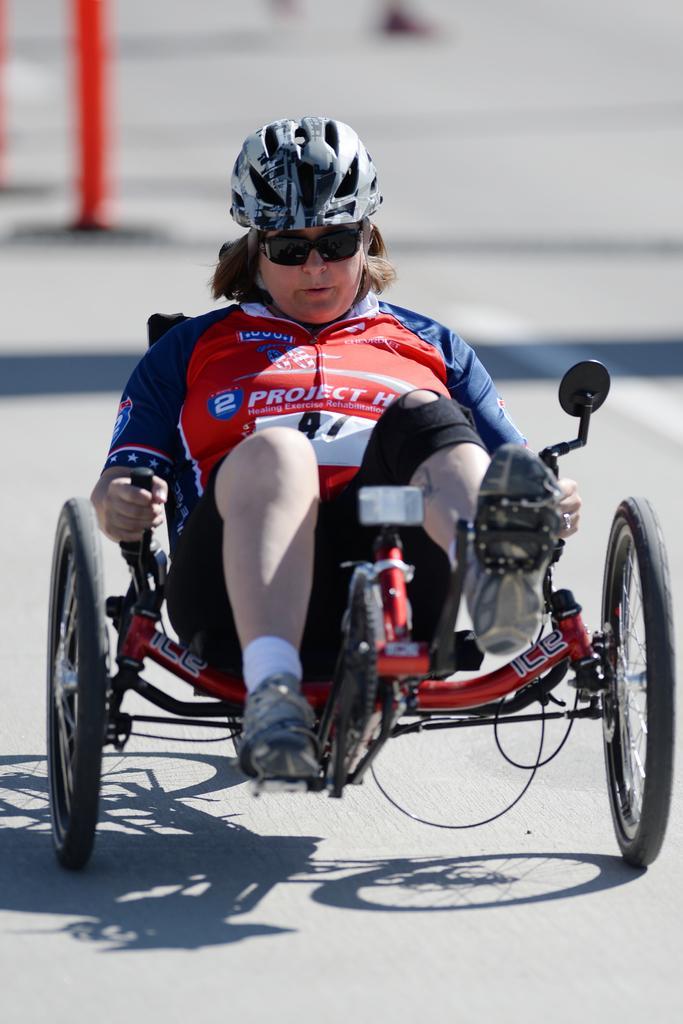Can you describe this image briefly? This person is sitting on a vehicle with wheels, wore goggles and helmet. Background it is blur. 